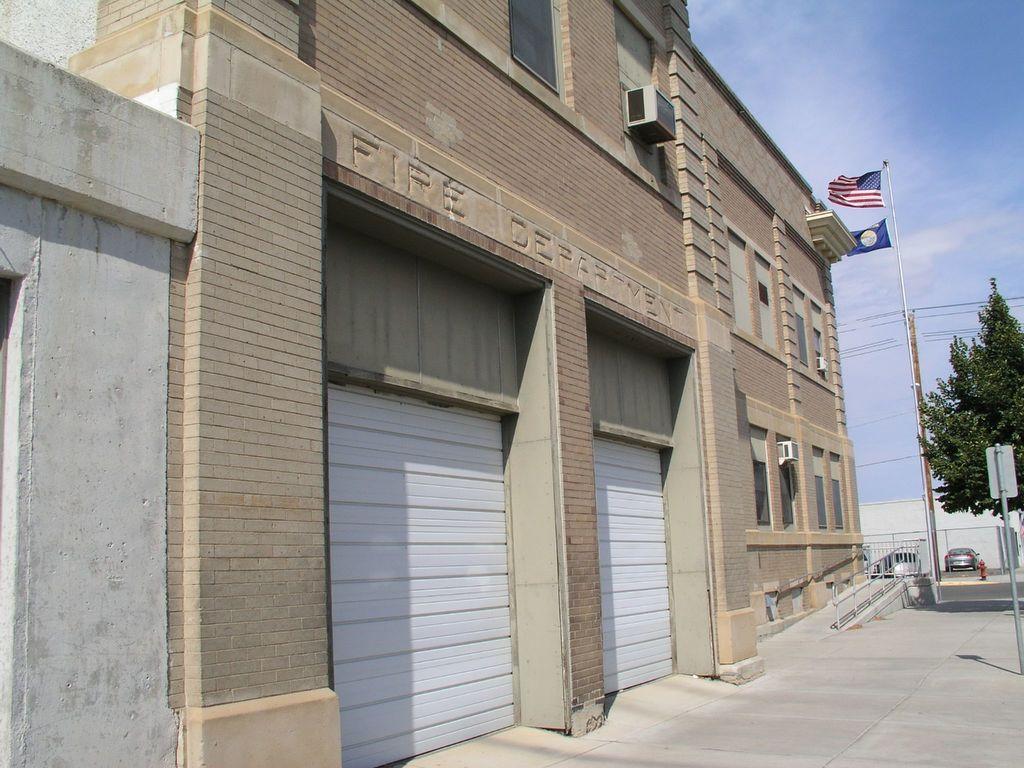Could you give a brief overview of what you see in this image? This is an outside view. Here I can see a building. On the right side there is a tree, flag, pole and I can see a car on the ground. At the top of the image I can see sky. 